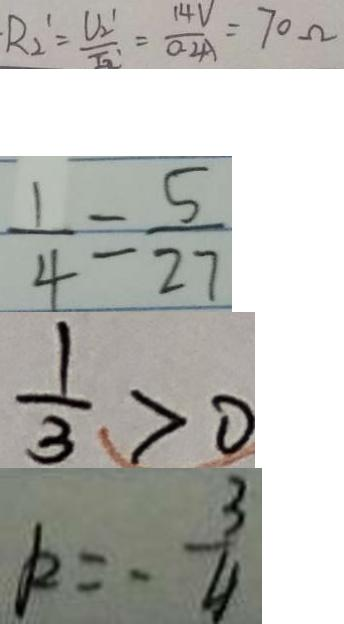<formula> <loc_0><loc_0><loc_500><loc_500>R _ { 2 } ^ { \prime } = \frac { U _ { 2 } ^ { 1 } } { I _ { 2 } ^ { \prime } } = \frac { 1 4 V } { 0 . 2 A } = 7 0 \Omega 
 \frac { 1 } { 4 } = \frac { 5 } { 2 7 } 
 \frac { 1 } { 3 } > 0 
 k = - \frac { 3 } { 4 }</formula> 